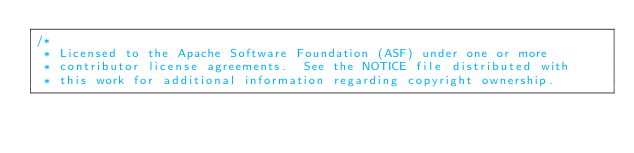Convert code to text. <code><loc_0><loc_0><loc_500><loc_500><_Scala_>/*
 * Licensed to the Apache Software Foundation (ASF) under one or more
 * contributor license agreements.  See the NOTICE file distributed with
 * this work for additional information regarding copyright ownership.</code> 